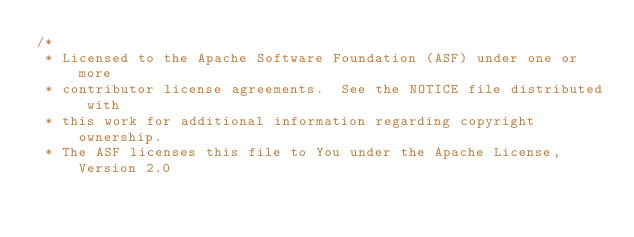<code> <loc_0><loc_0><loc_500><loc_500><_Scala_>/*
 * Licensed to the Apache Software Foundation (ASF) under one or more
 * contributor license agreements.  See the NOTICE file distributed with
 * this work for additional information regarding copyright ownership.
 * The ASF licenses this file to You under the Apache License, Version 2.0</code> 